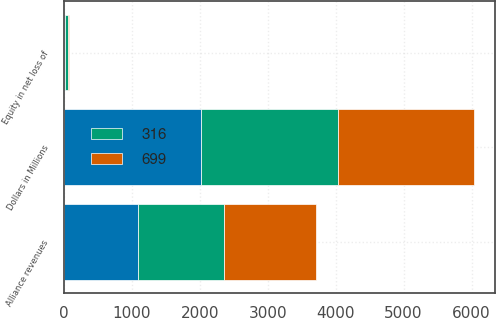Convert chart. <chart><loc_0><loc_0><loc_500><loc_500><stacked_bar_chart><ecel><fcel>Dollars in Millions<fcel>Alliance revenues<fcel>Equity in net loss of<nl><fcel>nan<fcel>2015<fcel>1096<fcel>17<nl><fcel>316<fcel>2014<fcel>1255<fcel>39<nl><fcel>699<fcel>2013<fcel>1366<fcel>17<nl></chart> 